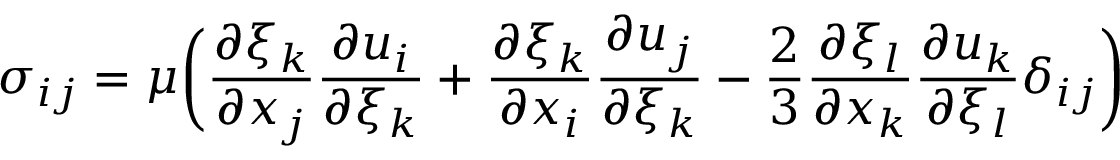<formula> <loc_0><loc_0><loc_500><loc_500>\sigma _ { i j } = \mu \left ( \frac { \partial \xi _ { k } } { \partial x _ { j } } \frac { \partial u _ { i } } { \partial \xi _ { k } } + \frac { \partial \xi _ { k } } { \partial x _ { i } } \frac { \partial u _ { j } } { \partial \xi _ { k } } - \frac { 2 } { 3 } \frac { \partial \xi _ { l } } { \partial x _ { k } } \frac { \partial u _ { k } } { \partial \xi _ { l } } \delta _ { i j } \right )</formula> 